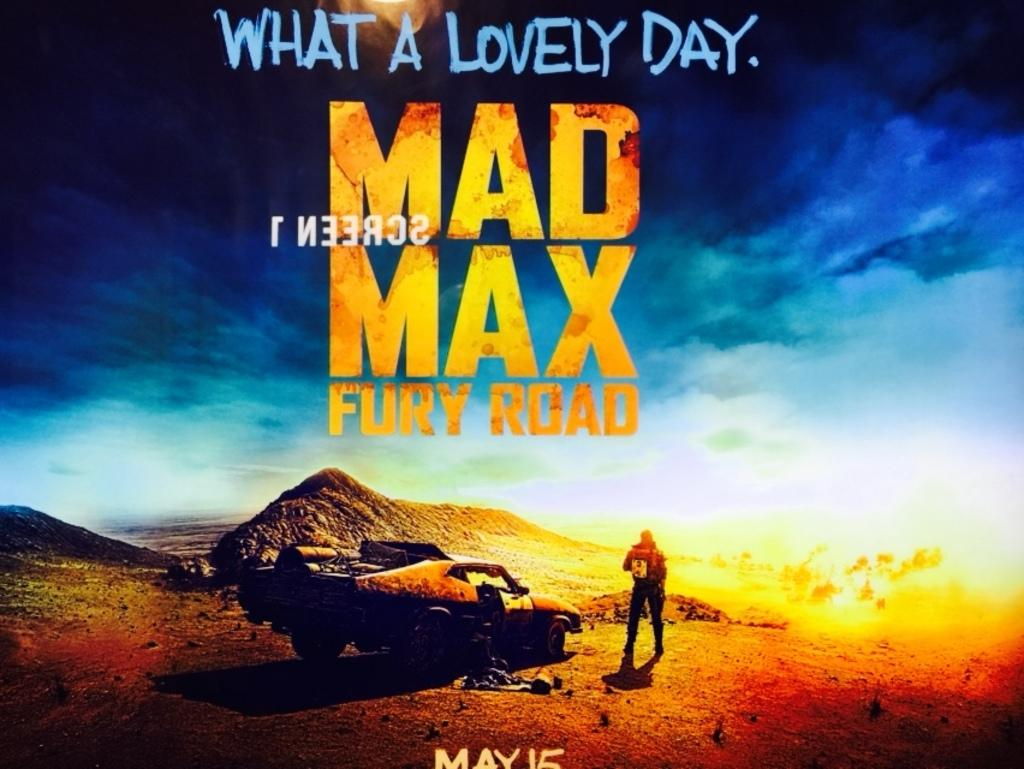<image>
Summarize the visual content of the image. A movie poster for Mad Max Fury Road, which reads "What a Lovely Day." at the top of the poster and "May 15" on the bottom. 